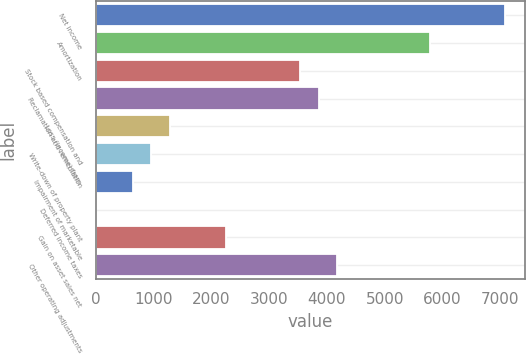<chart> <loc_0><loc_0><loc_500><loc_500><bar_chart><fcel>Net income<fcel>Amortization<fcel>Stock based compensation and<fcel>Reclamation and remediation<fcel>Loss (income) from<fcel>Write-down of property plant<fcel>Impairment of marketable<fcel>Deferred income taxes<fcel>Gain on asset sales net<fcel>Other operating adjustments<nl><fcel>7071.8<fcel>5786.2<fcel>3536.4<fcel>3857.8<fcel>1286.6<fcel>965.2<fcel>643.8<fcel>1<fcel>2250.8<fcel>4179.2<nl></chart> 